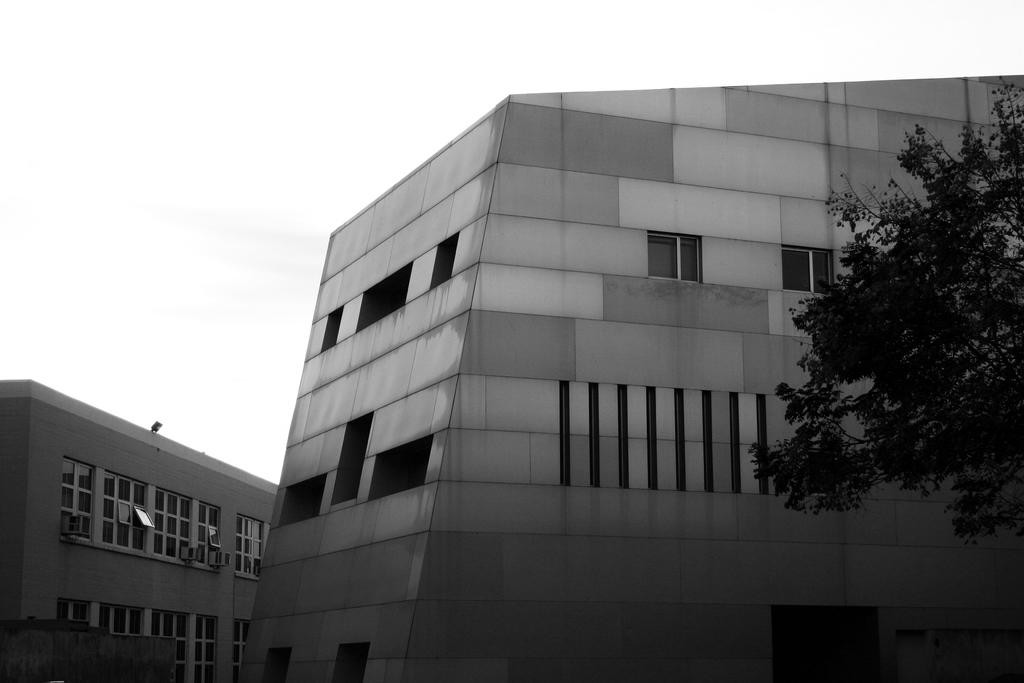What is the color scheme of the image? The image is black and white. What type of structures are visible in the image? There are buildings in the image. What are the main features of the buildings? The buildings have walls and windows. What can be seen on the right side of the image? There is a tree on the right side of the image. What type of crime is being committed in the image? There is no indication of any crime being committed in the image; it features black and white buildings with walls and windows, and a tree on the right side. What kind of loaf is being used to illuminate the buildings in the image? There is no loaf present in the image, and the buildings are illuminated by natural light or artificial lighting, not by a loaf. 